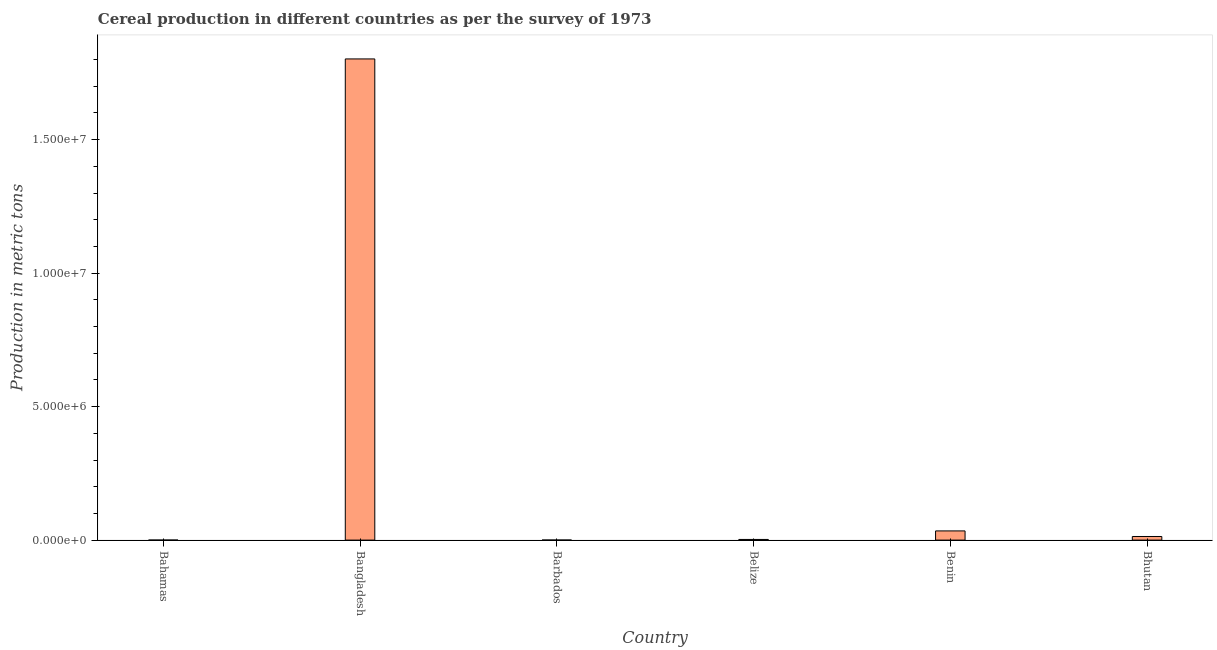Does the graph contain grids?
Your answer should be very brief. No. What is the title of the graph?
Ensure brevity in your answer.  Cereal production in different countries as per the survey of 1973. What is the label or title of the X-axis?
Your response must be concise. Country. What is the label or title of the Y-axis?
Provide a succinct answer. Production in metric tons. What is the cereal production in Barbados?
Offer a very short reply. 2000. Across all countries, what is the maximum cereal production?
Provide a succinct answer. 1.80e+07. Across all countries, what is the minimum cereal production?
Make the answer very short. 580. In which country was the cereal production minimum?
Offer a very short reply. Bahamas. What is the sum of the cereal production?
Keep it short and to the point. 1.85e+07. What is the difference between the cereal production in Bahamas and Barbados?
Your response must be concise. -1420. What is the average cereal production per country?
Keep it short and to the point. 3.09e+06. What is the median cereal production?
Offer a very short reply. 7.96e+04. What is the ratio of the cereal production in Bangladesh to that in Benin?
Ensure brevity in your answer.  52.36. Is the cereal production in Benin less than that in Bhutan?
Your response must be concise. No. Is the difference between the cereal production in Bahamas and Benin greater than the difference between any two countries?
Offer a terse response. No. What is the difference between the highest and the second highest cereal production?
Make the answer very short. 1.77e+07. Is the sum of the cereal production in Bangladesh and Bhutan greater than the maximum cereal production across all countries?
Make the answer very short. Yes. What is the difference between the highest and the lowest cereal production?
Provide a succinct answer. 1.80e+07. How many bars are there?
Keep it short and to the point. 6. What is the difference between two consecutive major ticks on the Y-axis?
Provide a succinct answer. 5.00e+06. What is the Production in metric tons of Bahamas?
Your answer should be compact. 580. What is the Production in metric tons of Bangladesh?
Your response must be concise. 1.80e+07. What is the Production in metric tons of Barbados?
Keep it short and to the point. 2000. What is the Production in metric tons in Belize?
Keep it short and to the point. 2.43e+04. What is the Production in metric tons in Benin?
Make the answer very short. 3.44e+05. What is the Production in metric tons of Bhutan?
Offer a terse response. 1.35e+05. What is the difference between the Production in metric tons in Bahamas and Bangladesh?
Your response must be concise. -1.80e+07. What is the difference between the Production in metric tons in Bahamas and Barbados?
Give a very brief answer. -1420. What is the difference between the Production in metric tons in Bahamas and Belize?
Ensure brevity in your answer.  -2.37e+04. What is the difference between the Production in metric tons in Bahamas and Benin?
Give a very brief answer. -3.44e+05. What is the difference between the Production in metric tons in Bahamas and Bhutan?
Offer a very short reply. -1.34e+05. What is the difference between the Production in metric tons in Bangladesh and Barbados?
Provide a succinct answer. 1.80e+07. What is the difference between the Production in metric tons in Bangladesh and Belize?
Give a very brief answer. 1.80e+07. What is the difference between the Production in metric tons in Bangladesh and Benin?
Your answer should be compact. 1.77e+07. What is the difference between the Production in metric tons in Bangladesh and Bhutan?
Give a very brief answer. 1.79e+07. What is the difference between the Production in metric tons in Barbados and Belize?
Keep it short and to the point. -2.23e+04. What is the difference between the Production in metric tons in Barbados and Benin?
Offer a very short reply. -3.42e+05. What is the difference between the Production in metric tons in Barbados and Bhutan?
Provide a short and direct response. -1.33e+05. What is the difference between the Production in metric tons in Belize and Benin?
Offer a very short reply. -3.20e+05. What is the difference between the Production in metric tons in Belize and Bhutan?
Your response must be concise. -1.11e+05. What is the difference between the Production in metric tons in Benin and Bhutan?
Offer a terse response. 2.09e+05. What is the ratio of the Production in metric tons in Bahamas to that in Barbados?
Provide a short and direct response. 0.29. What is the ratio of the Production in metric tons in Bahamas to that in Belize?
Offer a terse response. 0.02. What is the ratio of the Production in metric tons in Bahamas to that in Benin?
Offer a very short reply. 0. What is the ratio of the Production in metric tons in Bahamas to that in Bhutan?
Your response must be concise. 0. What is the ratio of the Production in metric tons in Bangladesh to that in Barbados?
Provide a succinct answer. 9010.76. What is the ratio of the Production in metric tons in Bangladesh to that in Belize?
Provide a succinct answer. 742.63. What is the ratio of the Production in metric tons in Bangladesh to that in Benin?
Your answer should be compact. 52.36. What is the ratio of the Production in metric tons in Bangladesh to that in Bhutan?
Offer a very short reply. 133.59. What is the ratio of the Production in metric tons in Barbados to that in Belize?
Ensure brevity in your answer.  0.08. What is the ratio of the Production in metric tons in Barbados to that in Benin?
Make the answer very short. 0.01. What is the ratio of the Production in metric tons in Barbados to that in Bhutan?
Make the answer very short. 0.01. What is the ratio of the Production in metric tons in Belize to that in Benin?
Make the answer very short. 0.07. What is the ratio of the Production in metric tons in Belize to that in Bhutan?
Your answer should be compact. 0.18. What is the ratio of the Production in metric tons in Benin to that in Bhutan?
Your answer should be compact. 2.55. 